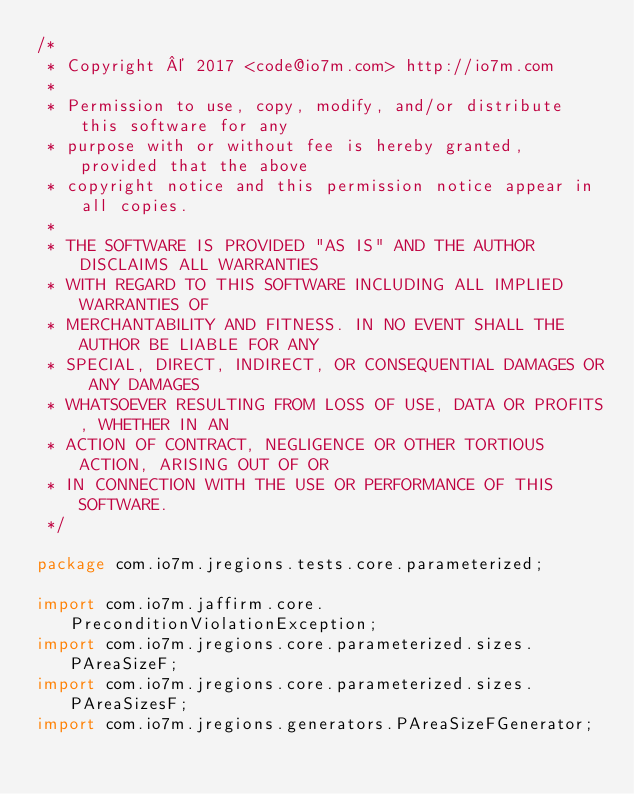<code> <loc_0><loc_0><loc_500><loc_500><_Java_>/*
 * Copyright © 2017 <code@io7m.com> http://io7m.com
 *
 * Permission to use, copy, modify, and/or distribute this software for any
 * purpose with or without fee is hereby granted, provided that the above
 * copyright notice and this permission notice appear in all copies.
 *
 * THE SOFTWARE IS PROVIDED "AS IS" AND THE AUTHOR DISCLAIMS ALL WARRANTIES
 * WITH REGARD TO THIS SOFTWARE INCLUDING ALL IMPLIED WARRANTIES OF
 * MERCHANTABILITY AND FITNESS. IN NO EVENT SHALL THE AUTHOR BE LIABLE FOR ANY
 * SPECIAL, DIRECT, INDIRECT, OR CONSEQUENTIAL DAMAGES OR ANY DAMAGES
 * WHATSOEVER RESULTING FROM LOSS OF USE, DATA OR PROFITS, WHETHER IN AN
 * ACTION OF CONTRACT, NEGLIGENCE OR OTHER TORTIOUS ACTION, ARISING OUT OF OR
 * IN CONNECTION WITH THE USE OR PERFORMANCE OF THIS SOFTWARE.
 */

package com.io7m.jregions.tests.core.parameterized;

import com.io7m.jaffirm.core.PreconditionViolationException;
import com.io7m.jregions.core.parameterized.sizes.PAreaSizeF;
import com.io7m.jregions.core.parameterized.sizes.PAreaSizesF;
import com.io7m.jregions.generators.PAreaSizeFGenerator;</code> 